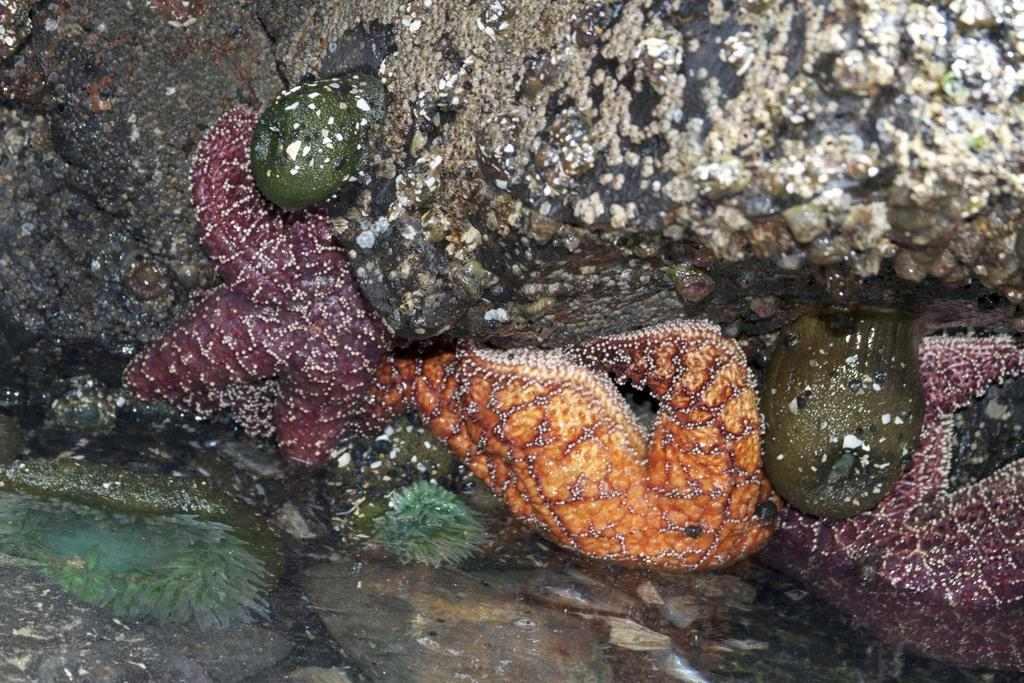What is located in the middle of the image? There are starfishes in the middle of the image. What is visible at the bottom of the image? There is water and stones visible at the bottom of the image. What can be seen at the top of the image? There is a rock at the top of the image. Who is the owner of the starfishes in the image? There is no indication of an owner for the starfishes in the image. What type of meeting is taking place in the image? There is no meeting depicted in the image; it features starfishes, water, stones, and a rock. 